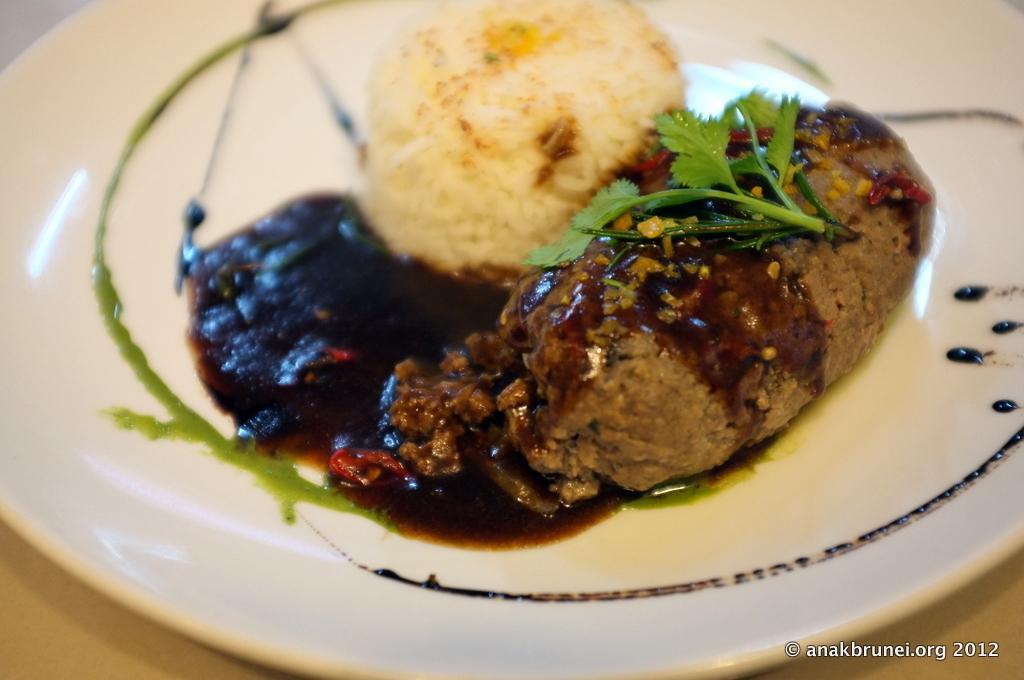Please provide a concise description of this image. These are the food items in a white color plate. 